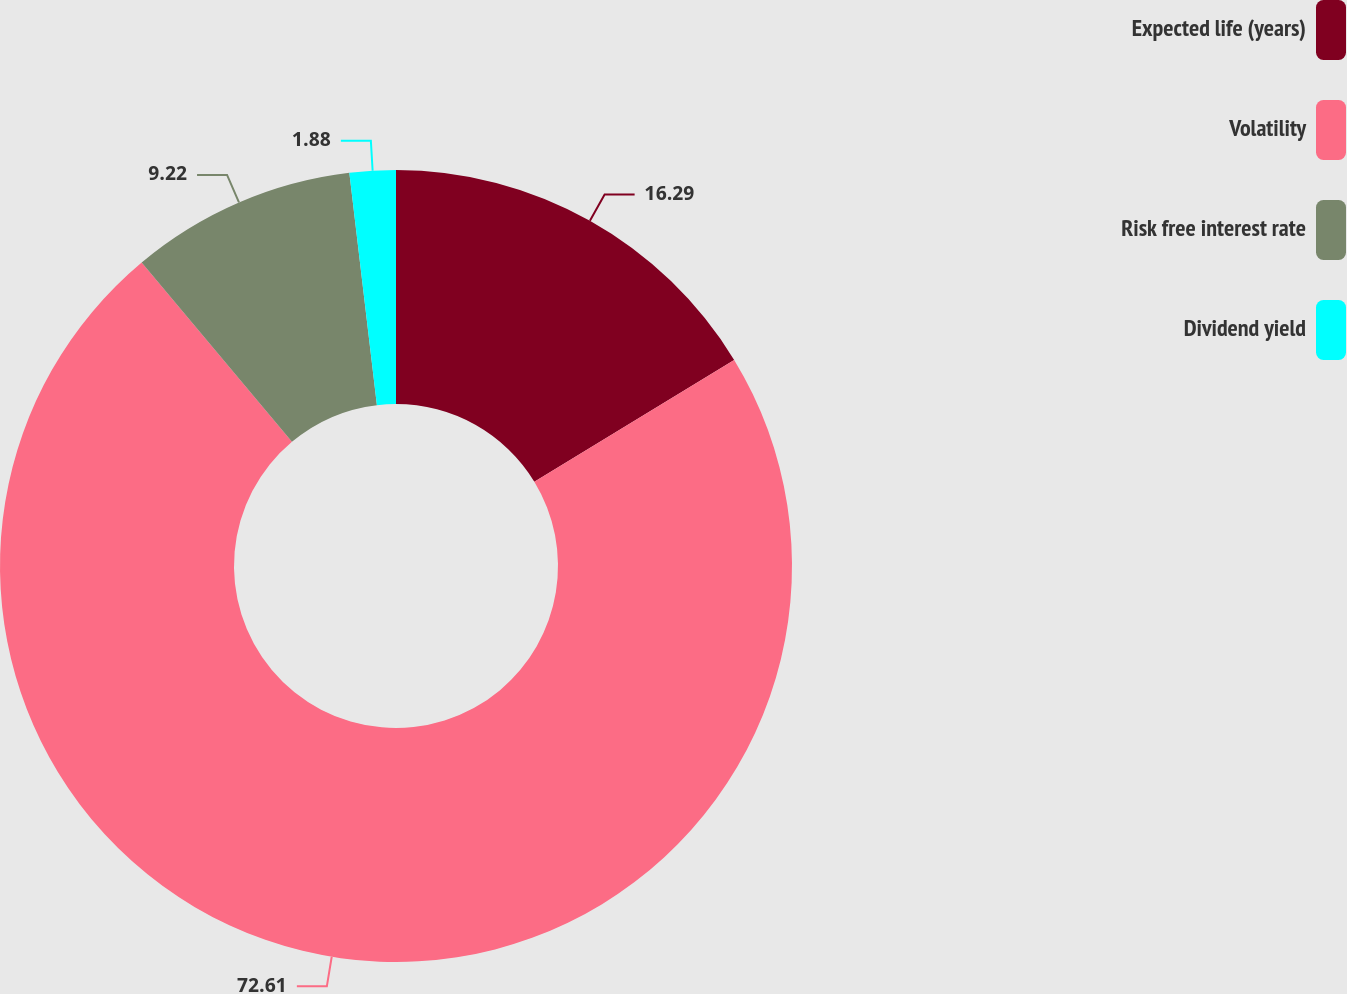<chart> <loc_0><loc_0><loc_500><loc_500><pie_chart><fcel>Expected life (years)<fcel>Volatility<fcel>Risk free interest rate<fcel>Dividend yield<nl><fcel>16.29%<fcel>72.61%<fcel>9.22%<fcel>1.88%<nl></chart> 